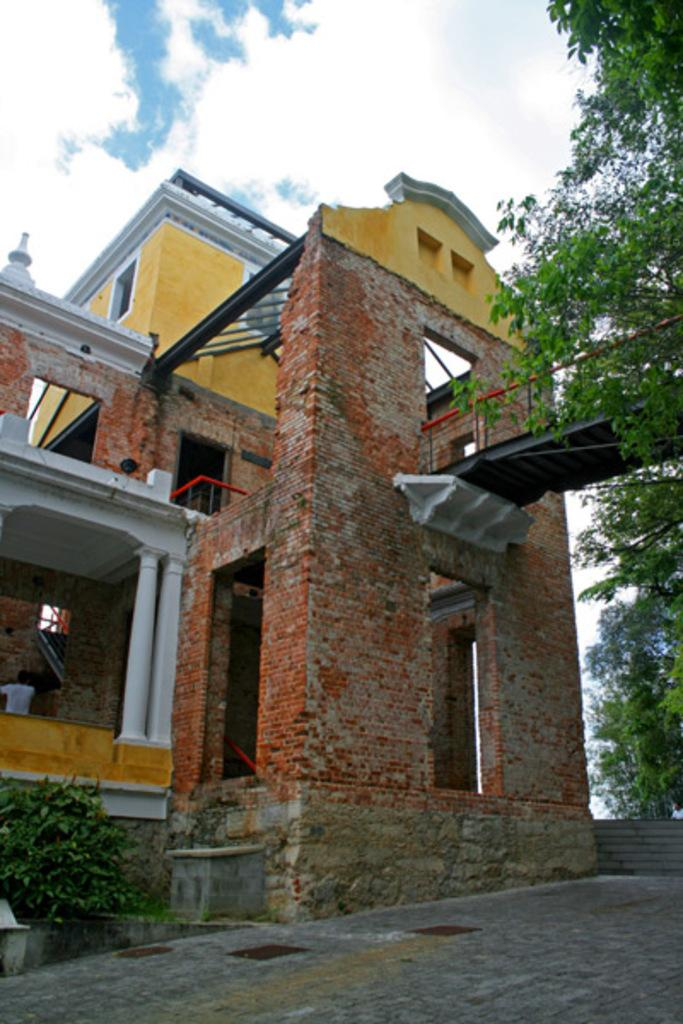What is the main structure in the middle of the image? There is a house in the middle of the image. What architectural features can be seen in the image? There are pillars in the image. What type of vegetation is on the right side of the image? There are trees on the right side of the image. What type of vegetation is at the bottom of the image? There are plants at the bottom of the image. What is visible beneath the house in the image? There is a floor visible in the image. What is visible at the top of the image? The sky is visible at the top of the image, and there are clouds in the sky. What type of pocket can be seen on the house in the image? There are no pockets visible on the house in the image. Can you tell me how many people are running in the image? There is no one running in the image; it features a house, pillars, trees, plants, a floor, and the sky with clouds. 